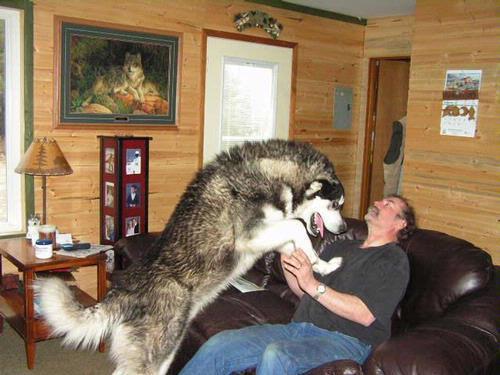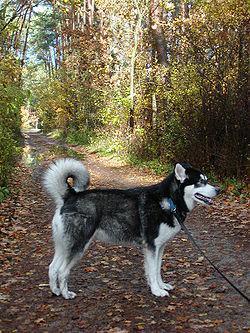The first image is the image on the left, the second image is the image on the right. Given the left and right images, does the statement "In one of the images, a Malamute is near a man who is sitting on a couch." hold true? Answer yes or no. Yes. The first image is the image on the left, the second image is the image on the right. Examine the images to the left and right. Is the description "One image shows a single dog standing in profile, and the other image shows a man sitting on an overstuffed couch near a big dog." accurate? Answer yes or no. Yes. 